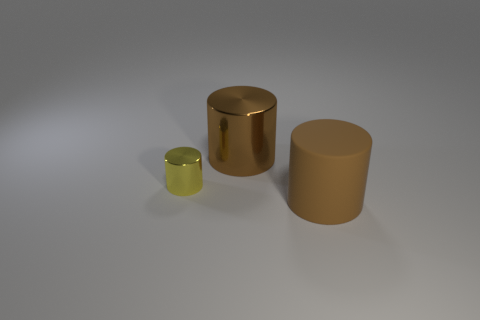Are there any other things that have the same size as the yellow metallic object?
Your answer should be compact. No. Are there more large brown objects to the right of the small yellow metal object than objects in front of the big metallic thing?
Your response must be concise. No. Do the brown shiny cylinder and the brown rubber thing have the same size?
Keep it short and to the point. Yes. The large metallic thing that is the same shape as the tiny shiny object is what color?
Provide a succinct answer. Brown. What number of other things are the same color as the rubber object?
Offer a terse response. 1. Are there more cylinders that are in front of the small yellow object than large purple spheres?
Ensure brevity in your answer.  Yes. What color is the metal object on the left side of the large brown cylinder that is left of the brown rubber object?
Make the answer very short. Yellow. What number of things are large brown shiny objects that are on the left side of the matte cylinder or cylinders that are behind the tiny object?
Provide a short and direct response. 1. The tiny thing is what color?
Make the answer very short. Yellow. What number of brown things have the same material as the small yellow thing?
Make the answer very short. 1. 